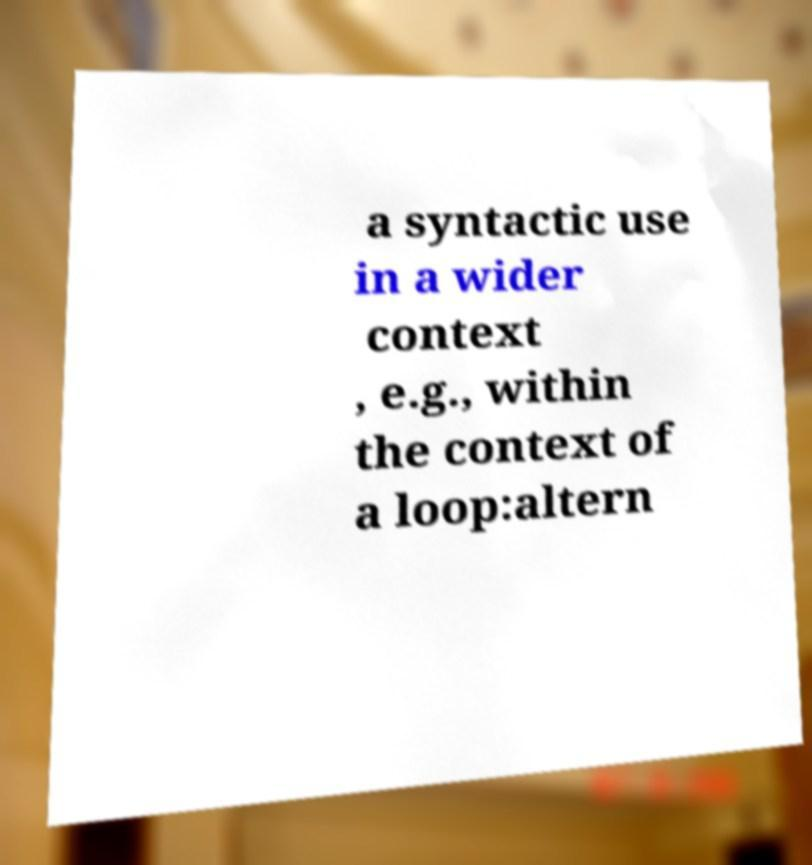Could you assist in decoding the text presented in this image and type it out clearly? a syntactic use in a wider context , e.g., within the context of a loop:altern 